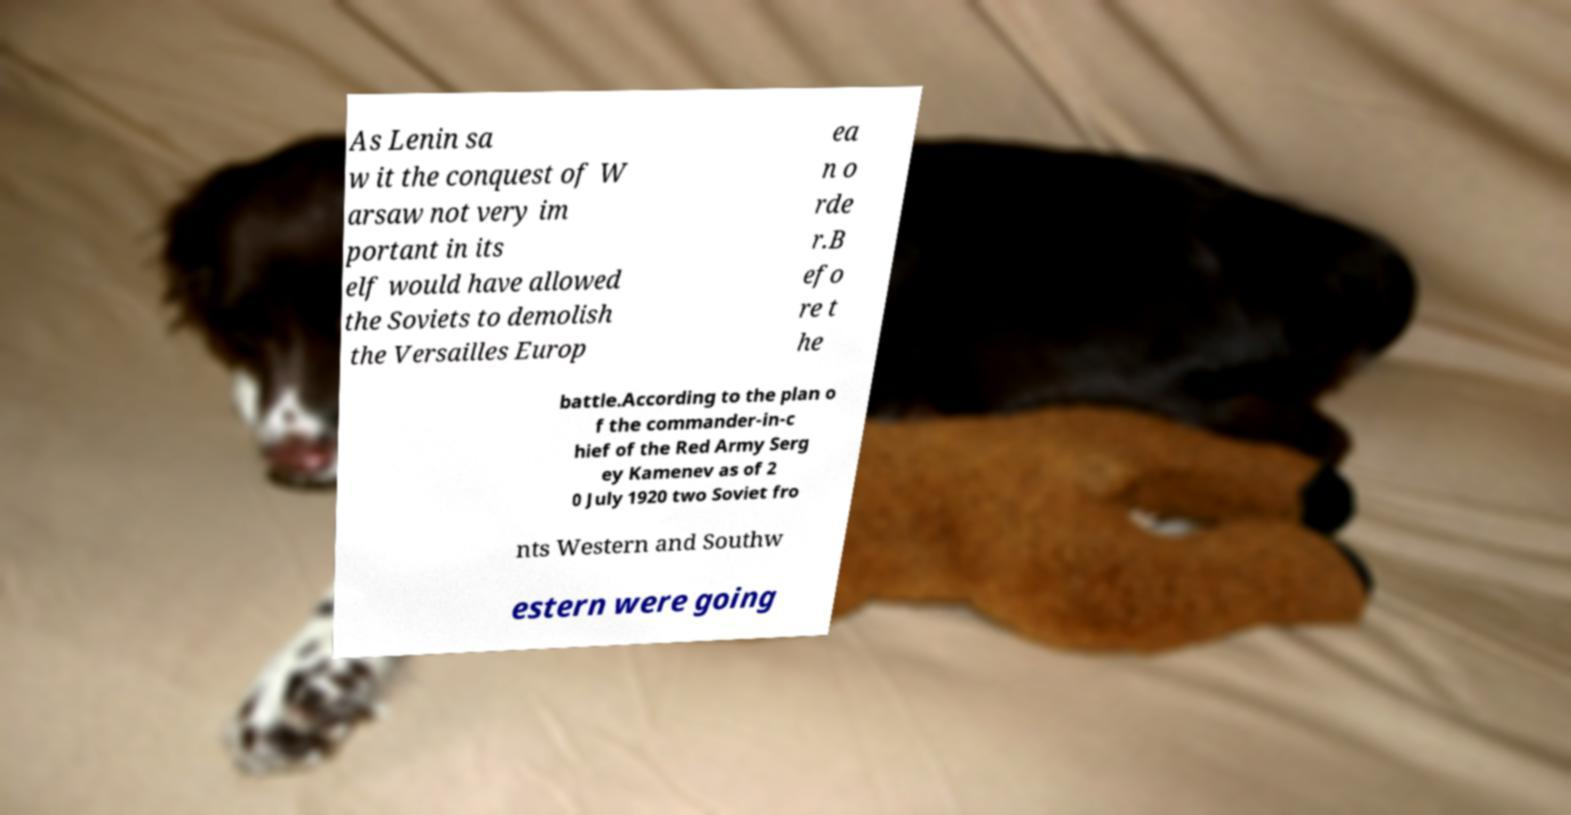There's text embedded in this image that I need extracted. Can you transcribe it verbatim? As Lenin sa w it the conquest of W arsaw not very im portant in its elf would have allowed the Soviets to demolish the Versailles Europ ea n o rde r.B efo re t he battle.According to the plan o f the commander-in-c hief of the Red Army Serg ey Kamenev as of 2 0 July 1920 two Soviet fro nts Western and Southw estern were going 